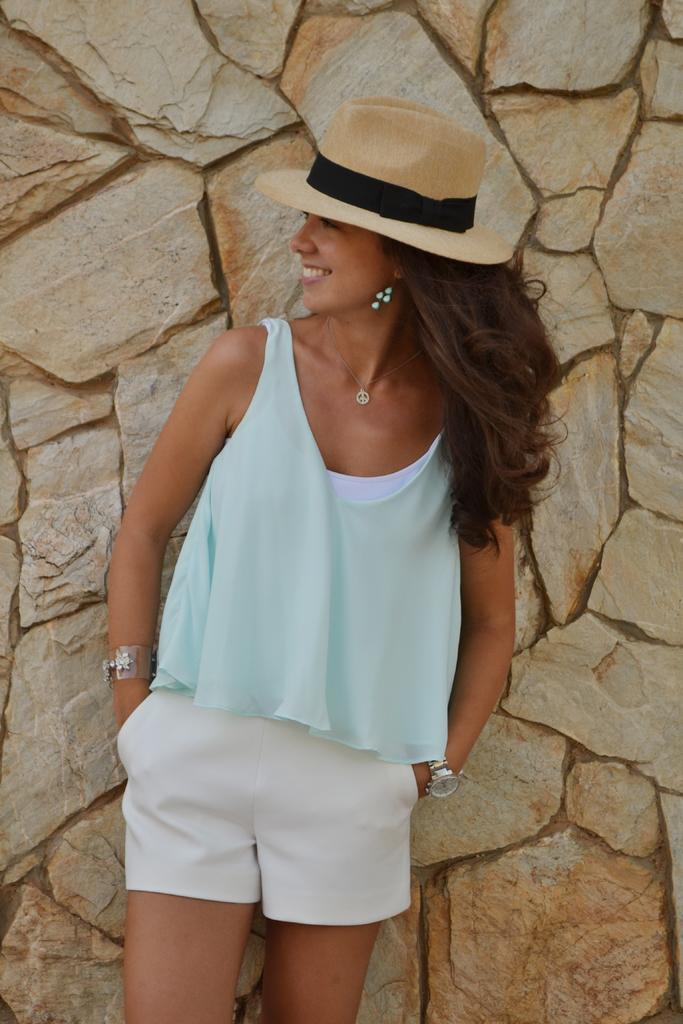Where was the image taken? The image is taken outdoors. What can be seen in the background of the image? There is a wall in the background of the image. Who is in the image? A woman is standing in the middle of the image. What is the woman's facial expression? The woman has a smiling face. What type of books can be seen on the chessboard in the image? There is no chessboard or books present in the image. 